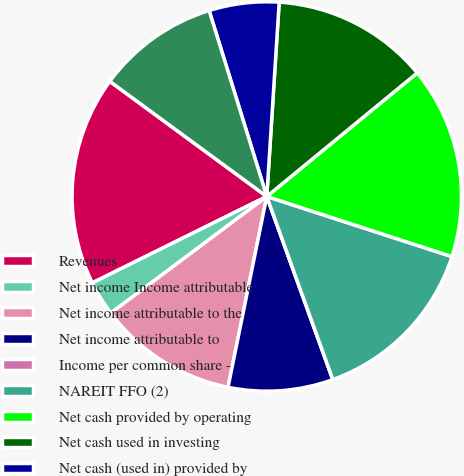Convert chart to OTSL. <chart><loc_0><loc_0><loc_500><loc_500><pie_chart><fcel>Revenues<fcel>Net income Income attributable<fcel>Net income attributable to the<fcel>Net income attributable to<fcel>Income per common share -<fcel>NAREIT FFO (2)<fcel>Net cash provided by operating<fcel>Net cash used in investing<fcel>Net cash (used in) provided by<fcel>Dividends paid to common<nl><fcel>17.39%<fcel>2.9%<fcel>11.59%<fcel>8.7%<fcel>0.0%<fcel>14.49%<fcel>15.94%<fcel>13.04%<fcel>5.8%<fcel>10.14%<nl></chart> 